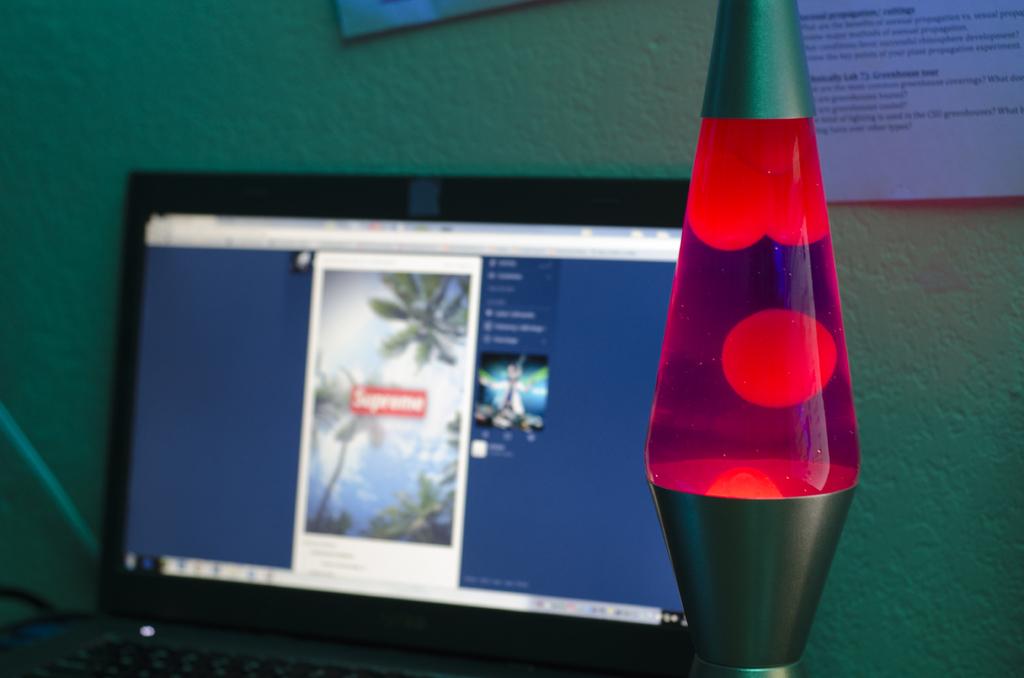What clothing brand is written in the red box?
Provide a succinct answer. Supreme. 